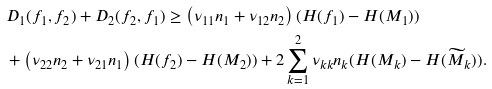Convert formula to latex. <formula><loc_0><loc_0><loc_500><loc_500>& D _ { 1 } ( f _ { 1 } , f _ { 2 } ) + D _ { 2 } ( f _ { 2 } , f _ { 1 } ) \geq \left ( \nu _ { 1 1 } n _ { 1 } + \nu _ { 1 2 } n _ { 2 } \right ) ( H ( f _ { 1 } ) - H ( M _ { 1 } ) ) \\ & + \left ( \nu _ { 2 2 } n _ { 2 } + \nu _ { 2 1 } n _ { 1 } \right ) ( H ( f _ { 2 } ) - H ( M _ { 2 } ) ) + 2 \sum _ { k = 1 } ^ { 2 } \nu _ { k k } n _ { k } ( H ( M _ { k } ) - H ( \widetilde { M } _ { k } ) ) .</formula> 